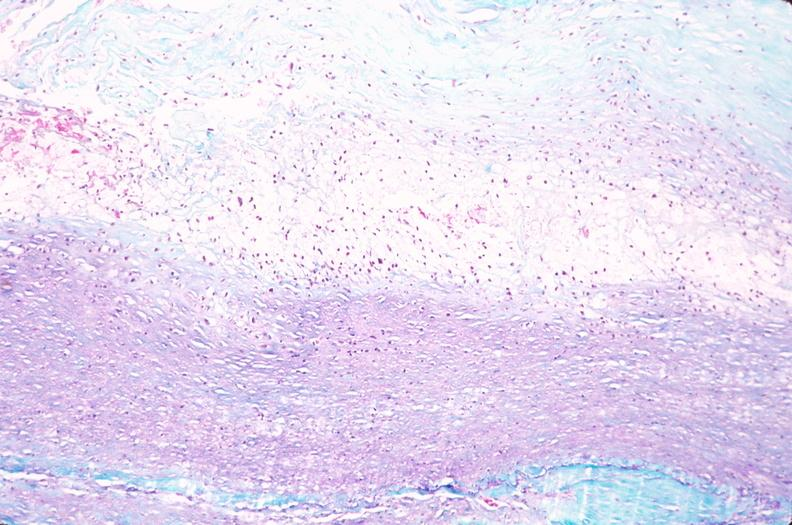does retroperitoneal liposarcoma show saphenous vein graft sclerosis?
Answer the question using a single word or phrase. No 